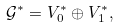<formula> <loc_0><loc_0><loc_500><loc_500>\mathcal { G } ^ { \ast } = V _ { 0 } ^ { \ast } \oplus V _ { 1 } ^ { \ast } ,</formula> 